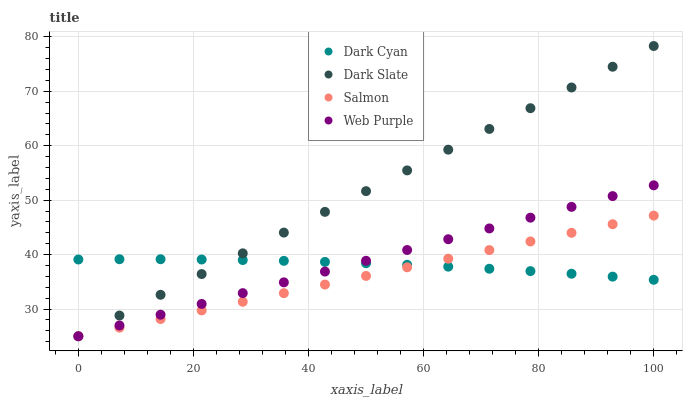Does Salmon have the minimum area under the curve?
Answer yes or no. Yes. Does Dark Slate have the maximum area under the curve?
Answer yes or no. Yes. Does Web Purple have the minimum area under the curve?
Answer yes or no. No. Does Web Purple have the maximum area under the curve?
Answer yes or no. No. Is Salmon the smoothest?
Answer yes or no. Yes. Is Dark Cyan the roughest?
Answer yes or no. Yes. Is Dark Slate the smoothest?
Answer yes or no. No. Is Dark Slate the roughest?
Answer yes or no. No. Does Dark Slate have the lowest value?
Answer yes or no. Yes. Does Dark Slate have the highest value?
Answer yes or no. Yes. Does Web Purple have the highest value?
Answer yes or no. No. Does Dark Slate intersect Dark Cyan?
Answer yes or no. Yes. Is Dark Slate less than Dark Cyan?
Answer yes or no. No. Is Dark Slate greater than Dark Cyan?
Answer yes or no. No. 